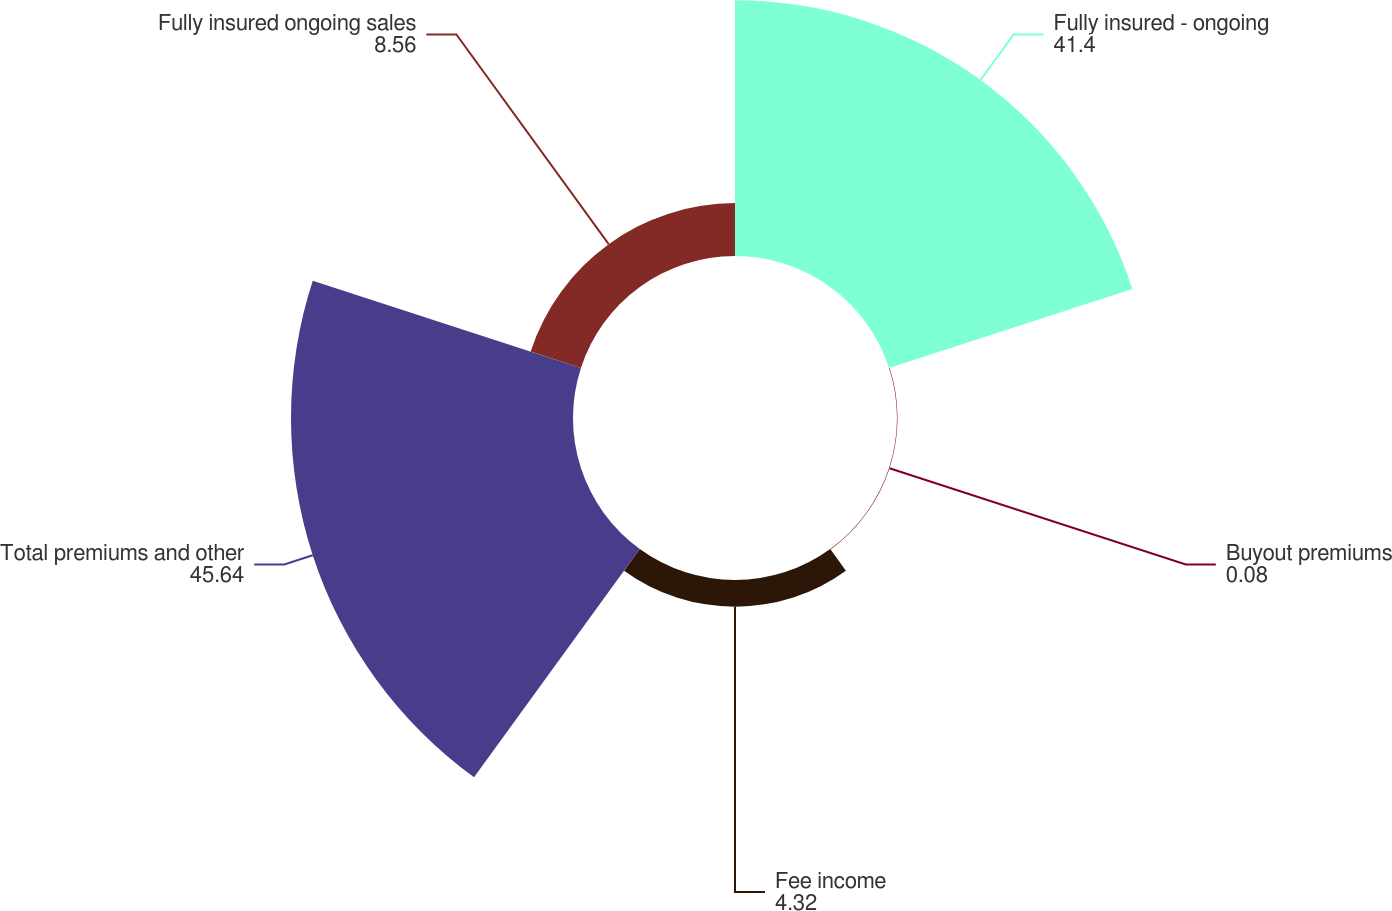Convert chart. <chart><loc_0><loc_0><loc_500><loc_500><pie_chart><fcel>Fully insured - ongoing<fcel>Buyout premiums<fcel>Fee income<fcel>Total premiums and other<fcel>Fully insured ongoing sales<nl><fcel>41.4%<fcel>0.08%<fcel>4.32%<fcel>45.64%<fcel>8.56%<nl></chart> 